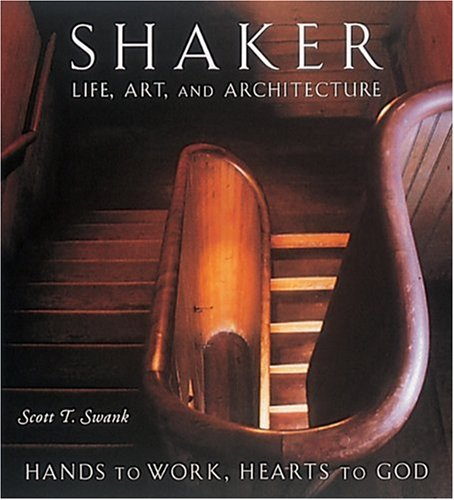Is this a comics book? No, this book is not a comic book; it is a scholarly text focusing on the religious, artistic, and architectural elements of the Shaker community. 